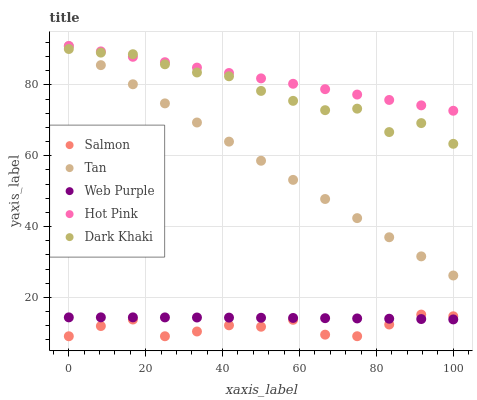Does Salmon have the minimum area under the curve?
Answer yes or no. Yes. Does Hot Pink have the maximum area under the curve?
Answer yes or no. Yes. Does Tan have the minimum area under the curve?
Answer yes or no. No. Does Tan have the maximum area under the curve?
Answer yes or no. No. Is Tan the smoothest?
Answer yes or no. Yes. Is Dark Khaki the roughest?
Answer yes or no. Yes. Is Hot Pink the smoothest?
Answer yes or no. No. Is Hot Pink the roughest?
Answer yes or no. No. Does Salmon have the lowest value?
Answer yes or no. Yes. Does Tan have the lowest value?
Answer yes or no. No. Does Hot Pink have the highest value?
Answer yes or no. Yes. Does Salmon have the highest value?
Answer yes or no. No. Is Web Purple less than Dark Khaki?
Answer yes or no. Yes. Is Dark Khaki greater than Web Purple?
Answer yes or no. Yes. Does Hot Pink intersect Tan?
Answer yes or no. Yes. Is Hot Pink less than Tan?
Answer yes or no. No. Is Hot Pink greater than Tan?
Answer yes or no. No. Does Web Purple intersect Dark Khaki?
Answer yes or no. No. 